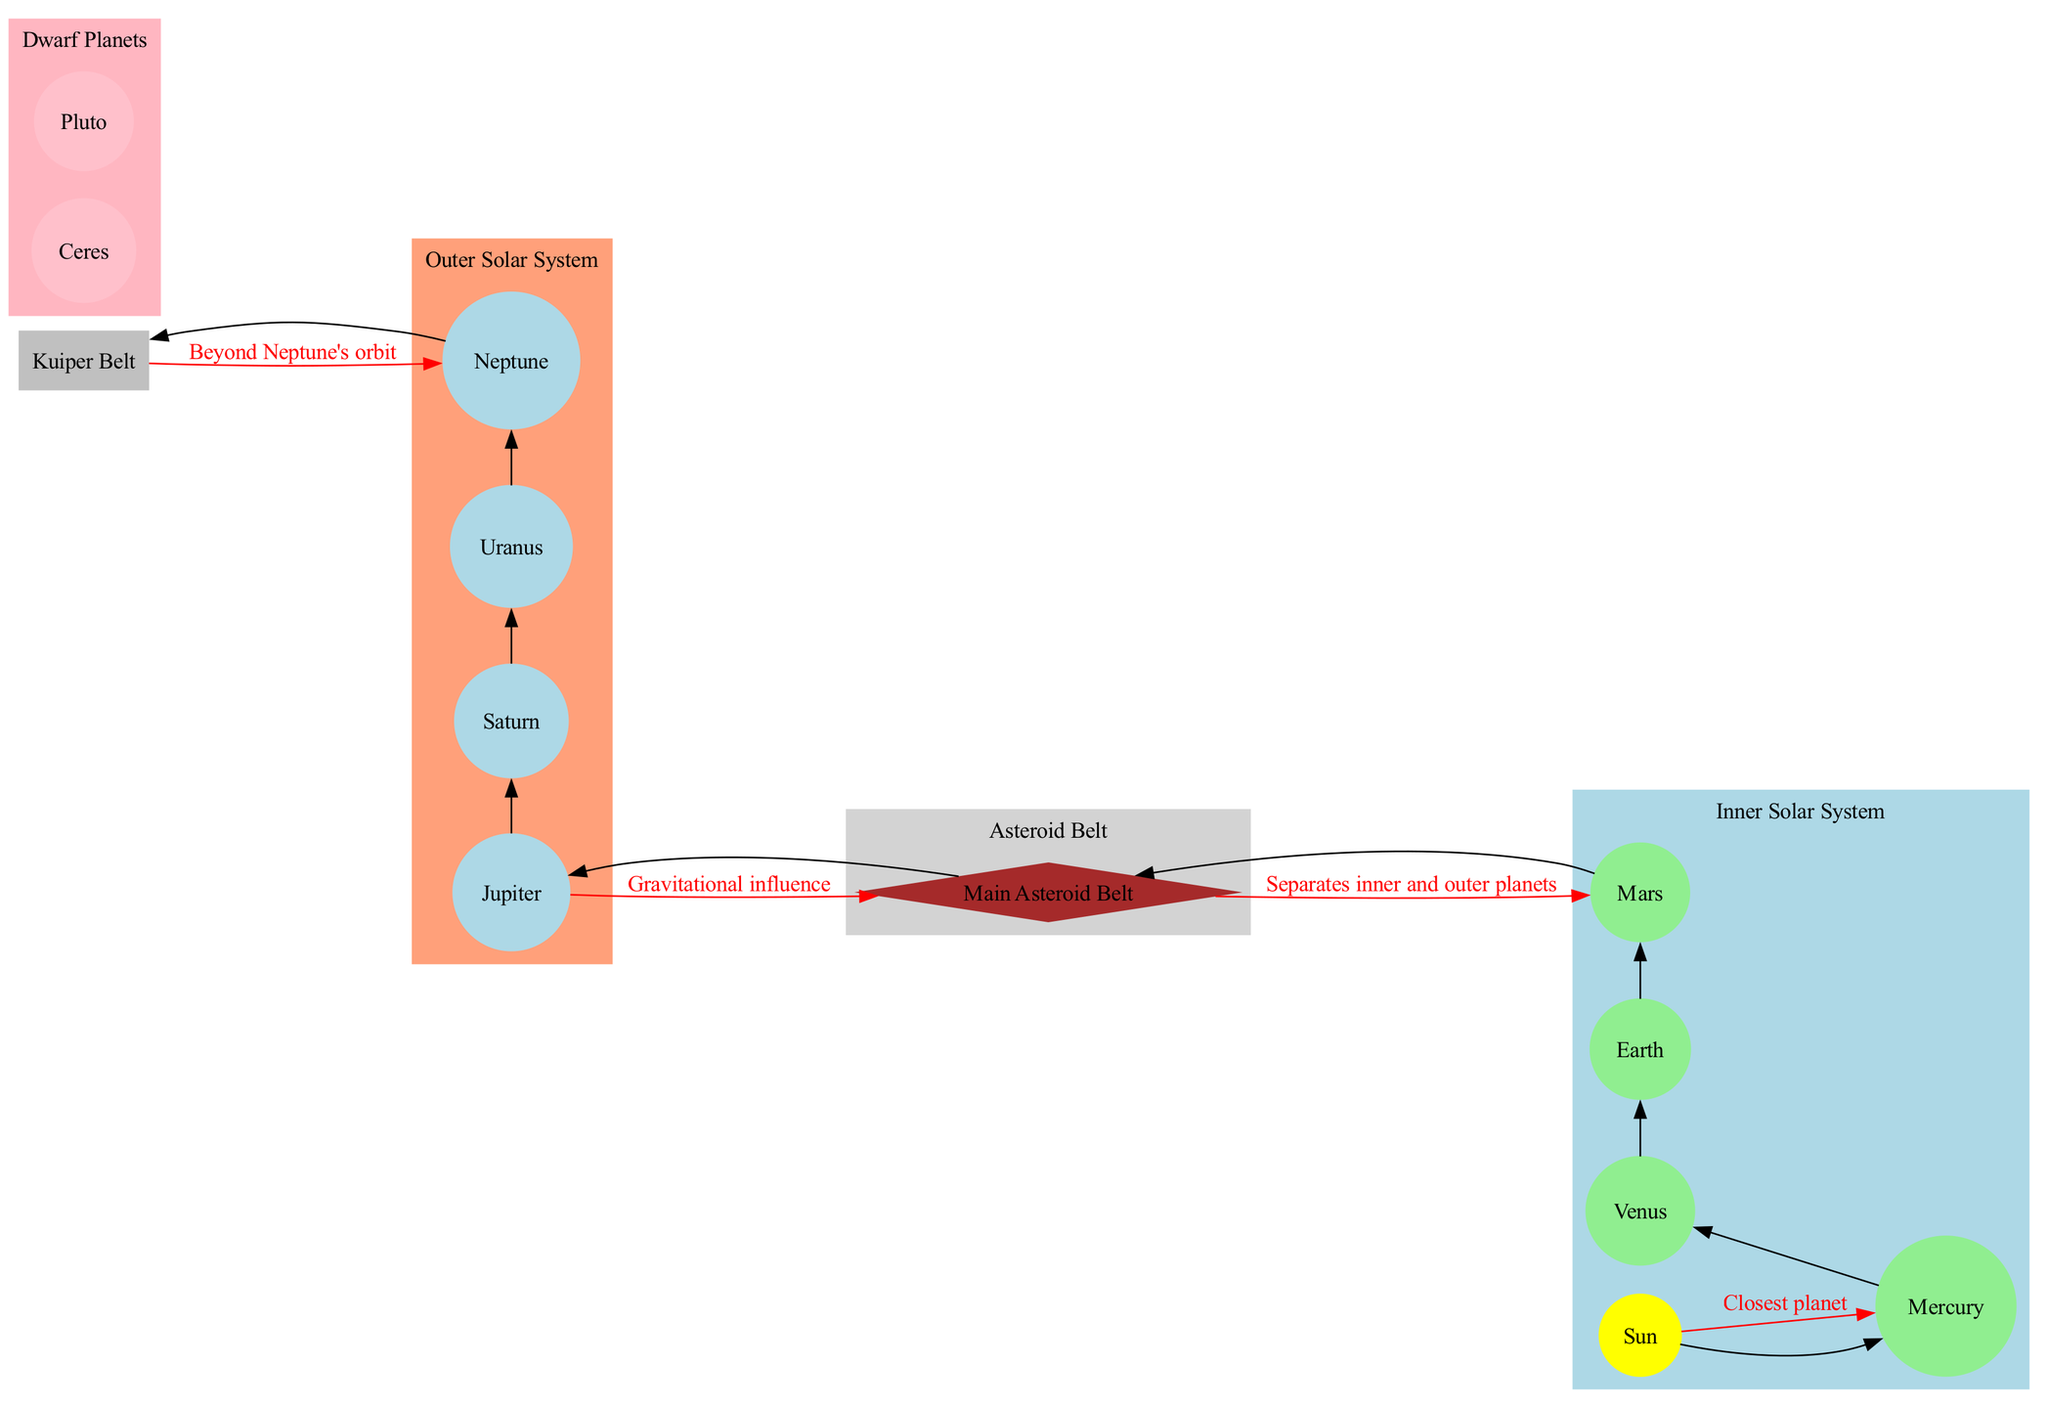What is the central object of the solar system? The diagram clearly marks the "Sun" at the center, indicating it as the primary object around which all other celestial bodies orbit.
Answer: Sun How many dwarf planets are illustrated in the diagram? The diagram lists "Ceres" and "Pluto" as the dwarf planets, counting them gives a total of 2.
Answer: 2 Which planet separates the inner and outer solar system? The "Main Asteroid Belt" is depicted between the inner planets and the outer planets, signifying its role as the boundary between these two regions.
Answer: Main Asteroid Belt What color represents the outer planets in the diagram? The outer planets, including Jupiter, Saturn, Uranus, and Neptune, are enclosed in a light salmon colored cluster, which visually distinguishes them from other celestial objects.
Answer: Lightsalmon Which planet has the closest proximity to the Sun? The diagram explicitly states that "Mercury" is the closest planet to the Sun, indicating its position closest in the solar system layout.
Answer: Mercury What does the label on the connection from Jupiter to the Main Asteroid Belt indicate? The connection is labeled "Gravitational influence", suggesting that Jupiter exerts a significant gravitational force affecting the Main Asteroid Belt.
Answer: Gravitational influence Identify the belt that lies beyond Neptune's orbit. The diagram labels the "Kuiper Belt" as the region located beyond Neptune, indicating its position in the solar system's layout.
Answer: Kuiper Belt Which connection highlights the influence of the Sun over Mercury? The connection from "Sun" to "Mercury" is labeled "Closest planet", which emphasizes the proximity and the gravitational effect the Sun has on Mercury.
Answer: Closest planet How many inner planets are depicted in the solar system? The diagram lists "Mercury", "Venus", "Earth", and "Mars" as the inner planets, providing a count of 4.
Answer: 4 